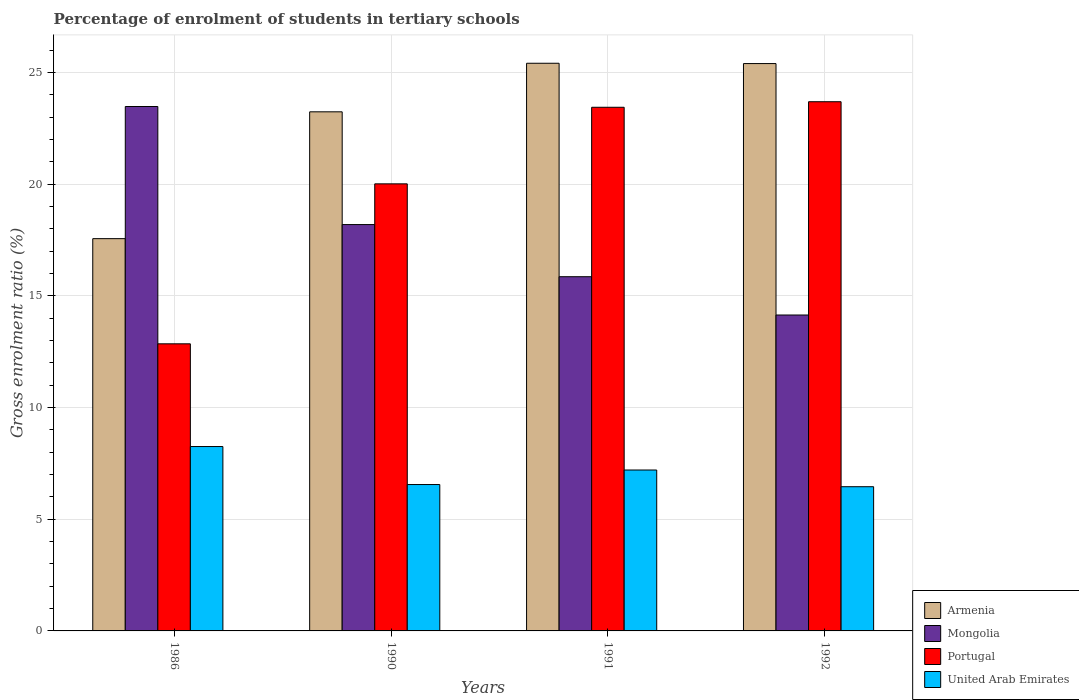How many different coloured bars are there?
Provide a short and direct response. 4. How many groups of bars are there?
Make the answer very short. 4. Are the number of bars per tick equal to the number of legend labels?
Offer a very short reply. Yes. How many bars are there on the 2nd tick from the left?
Offer a terse response. 4. What is the label of the 2nd group of bars from the left?
Provide a succinct answer. 1990. In how many cases, is the number of bars for a given year not equal to the number of legend labels?
Your answer should be very brief. 0. What is the percentage of students enrolled in tertiary schools in Portugal in 1990?
Provide a succinct answer. 20.02. Across all years, what is the maximum percentage of students enrolled in tertiary schools in United Arab Emirates?
Make the answer very short. 8.26. Across all years, what is the minimum percentage of students enrolled in tertiary schools in Portugal?
Offer a terse response. 12.86. In which year was the percentage of students enrolled in tertiary schools in Armenia maximum?
Keep it short and to the point. 1991. In which year was the percentage of students enrolled in tertiary schools in Portugal minimum?
Offer a terse response. 1986. What is the total percentage of students enrolled in tertiary schools in Mongolia in the graph?
Provide a succinct answer. 71.69. What is the difference between the percentage of students enrolled in tertiary schools in Portugal in 1991 and that in 1992?
Ensure brevity in your answer.  -0.25. What is the difference between the percentage of students enrolled in tertiary schools in Mongolia in 1986 and the percentage of students enrolled in tertiary schools in Portugal in 1990?
Your response must be concise. 3.46. What is the average percentage of students enrolled in tertiary schools in Mongolia per year?
Make the answer very short. 17.92. In the year 1990, what is the difference between the percentage of students enrolled in tertiary schools in Mongolia and percentage of students enrolled in tertiary schools in Armenia?
Your answer should be very brief. -5.05. In how many years, is the percentage of students enrolled in tertiary schools in United Arab Emirates greater than 21 %?
Make the answer very short. 0. What is the ratio of the percentage of students enrolled in tertiary schools in Armenia in 1986 to that in 1991?
Keep it short and to the point. 0.69. Is the percentage of students enrolled in tertiary schools in Portugal in 1990 less than that in 1991?
Offer a terse response. Yes. Is the difference between the percentage of students enrolled in tertiary schools in Mongolia in 1991 and 1992 greater than the difference between the percentage of students enrolled in tertiary schools in Armenia in 1991 and 1992?
Your response must be concise. Yes. What is the difference between the highest and the second highest percentage of students enrolled in tertiary schools in United Arab Emirates?
Keep it short and to the point. 1.05. What is the difference between the highest and the lowest percentage of students enrolled in tertiary schools in United Arab Emirates?
Your answer should be compact. 1.8. Is the sum of the percentage of students enrolled in tertiary schools in Portugal in 1990 and 1992 greater than the maximum percentage of students enrolled in tertiary schools in United Arab Emirates across all years?
Ensure brevity in your answer.  Yes. What does the 1st bar from the left in 1990 represents?
Offer a terse response. Armenia. What does the 3rd bar from the right in 1990 represents?
Give a very brief answer. Mongolia. How many years are there in the graph?
Your response must be concise. 4. What is the difference between two consecutive major ticks on the Y-axis?
Give a very brief answer. 5. Does the graph contain grids?
Give a very brief answer. Yes. Where does the legend appear in the graph?
Your response must be concise. Bottom right. How are the legend labels stacked?
Offer a terse response. Vertical. What is the title of the graph?
Keep it short and to the point. Percentage of enrolment of students in tertiary schools. Does "Malta" appear as one of the legend labels in the graph?
Make the answer very short. No. What is the label or title of the Y-axis?
Your answer should be very brief. Gross enrolment ratio (%). What is the Gross enrolment ratio (%) of Armenia in 1986?
Offer a terse response. 17.57. What is the Gross enrolment ratio (%) in Mongolia in 1986?
Offer a very short reply. 23.48. What is the Gross enrolment ratio (%) in Portugal in 1986?
Keep it short and to the point. 12.86. What is the Gross enrolment ratio (%) in United Arab Emirates in 1986?
Provide a succinct answer. 8.26. What is the Gross enrolment ratio (%) of Armenia in 1990?
Your answer should be very brief. 23.25. What is the Gross enrolment ratio (%) in Mongolia in 1990?
Your answer should be compact. 18.2. What is the Gross enrolment ratio (%) of Portugal in 1990?
Offer a terse response. 20.02. What is the Gross enrolment ratio (%) in United Arab Emirates in 1990?
Keep it short and to the point. 6.56. What is the Gross enrolment ratio (%) in Armenia in 1991?
Give a very brief answer. 25.42. What is the Gross enrolment ratio (%) of Mongolia in 1991?
Offer a very short reply. 15.86. What is the Gross enrolment ratio (%) in Portugal in 1991?
Provide a short and direct response. 23.45. What is the Gross enrolment ratio (%) of United Arab Emirates in 1991?
Make the answer very short. 7.21. What is the Gross enrolment ratio (%) in Armenia in 1992?
Ensure brevity in your answer.  25.41. What is the Gross enrolment ratio (%) in Mongolia in 1992?
Your response must be concise. 14.15. What is the Gross enrolment ratio (%) of Portugal in 1992?
Your answer should be very brief. 23.7. What is the Gross enrolment ratio (%) in United Arab Emirates in 1992?
Provide a short and direct response. 6.46. Across all years, what is the maximum Gross enrolment ratio (%) in Armenia?
Your response must be concise. 25.42. Across all years, what is the maximum Gross enrolment ratio (%) in Mongolia?
Offer a very short reply. 23.48. Across all years, what is the maximum Gross enrolment ratio (%) of Portugal?
Ensure brevity in your answer.  23.7. Across all years, what is the maximum Gross enrolment ratio (%) of United Arab Emirates?
Keep it short and to the point. 8.26. Across all years, what is the minimum Gross enrolment ratio (%) of Armenia?
Ensure brevity in your answer.  17.57. Across all years, what is the minimum Gross enrolment ratio (%) of Mongolia?
Your answer should be compact. 14.15. Across all years, what is the minimum Gross enrolment ratio (%) of Portugal?
Offer a terse response. 12.86. Across all years, what is the minimum Gross enrolment ratio (%) of United Arab Emirates?
Make the answer very short. 6.46. What is the total Gross enrolment ratio (%) in Armenia in the graph?
Provide a short and direct response. 91.64. What is the total Gross enrolment ratio (%) in Mongolia in the graph?
Your response must be concise. 71.69. What is the total Gross enrolment ratio (%) in Portugal in the graph?
Your answer should be compact. 80.03. What is the total Gross enrolment ratio (%) of United Arab Emirates in the graph?
Provide a short and direct response. 28.48. What is the difference between the Gross enrolment ratio (%) of Armenia in 1986 and that in 1990?
Ensure brevity in your answer.  -5.68. What is the difference between the Gross enrolment ratio (%) in Mongolia in 1986 and that in 1990?
Give a very brief answer. 5.29. What is the difference between the Gross enrolment ratio (%) of Portugal in 1986 and that in 1990?
Offer a terse response. -7.16. What is the difference between the Gross enrolment ratio (%) of United Arab Emirates in 1986 and that in 1990?
Provide a short and direct response. 1.7. What is the difference between the Gross enrolment ratio (%) in Armenia in 1986 and that in 1991?
Give a very brief answer. -7.85. What is the difference between the Gross enrolment ratio (%) of Mongolia in 1986 and that in 1991?
Offer a terse response. 7.62. What is the difference between the Gross enrolment ratio (%) of Portugal in 1986 and that in 1991?
Offer a terse response. -10.59. What is the difference between the Gross enrolment ratio (%) in United Arab Emirates in 1986 and that in 1991?
Give a very brief answer. 1.05. What is the difference between the Gross enrolment ratio (%) in Armenia in 1986 and that in 1992?
Ensure brevity in your answer.  -7.84. What is the difference between the Gross enrolment ratio (%) of Mongolia in 1986 and that in 1992?
Provide a succinct answer. 9.34. What is the difference between the Gross enrolment ratio (%) of Portugal in 1986 and that in 1992?
Your answer should be very brief. -10.84. What is the difference between the Gross enrolment ratio (%) of United Arab Emirates in 1986 and that in 1992?
Ensure brevity in your answer.  1.8. What is the difference between the Gross enrolment ratio (%) in Armenia in 1990 and that in 1991?
Provide a succinct answer. -2.17. What is the difference between the Gross enrolment ratio (%) of Mongolia in 1990 and that in 1991?
Provide a succinct answer. 2.33. What is the difference between the Gross enrolment ratio (%) in Portugal in 1990 and that in 1991?
Offer a terse response. -3.43. What is the difference between the Gross enrolment ratio (%) of United Arab Emirates in 1990 and that in 1991?
Provide a succinct answer. -0.65. What is the difference between the Gross enrolment ratio (%) in Armenia in 1990 and that in 1992?
Your answer should be very brief. -2.16. What is the difference between the Gross enrolment ratio (%) in Mongolia in 1990 and that in 1992?
Provide a short and direct response. 4.05. What is the difference between the Gross enrolment ratio (%) of Portugal in 1990 and that in 1992?
Ensure brevity in your answer.  -3.68. What is the difference between the Gross enrolment ratio (%) in United Arab Emirates in 1990 and that in 1992?
Offer a very short reply. 0.1. What is the difference between the Gross enrolment ratio (%) of Armenia in 1991 and that in 1992?
Keep it short and to the point. 0.01. What is the difference between the Gross enrolment ratio (%) in Mongolia in 1991 and that in 1992?
Provide a succinct answer. 1.72. What is the difference between the Gross enrolment ratio (%) in Portugal in 1991 and that in 1992?
Provide a succinct answer. -0.25. What is the difference between the Gross enrolment ratio (%) in United Arab Emirates in 1991 and that in 1992?
Your answer should be compact. 0.75. What is the difference between the Gross enrolment ratio (%) in Armenia in 1986 and the Gross enrolment ratio (%) in Mongolia in 1990?
Keep it short and to the point. -0.63. What is the difference between the Gross enrolment ratio (%) in Armenia in 1986 and the Gross enrolment ratio (%) in Portugal in 1990?
Ensure brevity in your answer.  -2.45. What is the difference between the Gross enrolment ratio (%) of Armenia in 1986 and the Gross enrolment ratio (%) of United Arab Emirates in 1990?
Ensure brevity in your answer.  11.01. What is the difference between the Gross enrolment ratio (%) of Mongolia in 1986 and the Gross enrolment ratio (%) of Portugal in 1990?
Provide a succinct answer. 3.46. What is the difference between the Gross enrolment ratio (%) of Mongolia in 1986 and the Gross enrolment ratio (%) of United Arab Emirates in 1990?
Provide a short and direct response. 16.93. What is the difference between the Gross enrolment ratio (%) in Portugal in 1986 and the Gross enrolment ratio (%) in United Arab Emirates in 1990?
Offer a very short reply. 6.3. What is the difference between the Gross enrolment ratio (%) of Armenia in 1986 and the Gross enrolment ratio (%) of Mongolia in 1991?
Offer a terse response. 1.7. What is the difference between the Gross enrolment ratio (%) in Armenia in 1986 and the Gross enrolment ratio (%) in Portugal in 1991?
Provide a short and direct response. -5.88. What is the difference between the Gross enrolment ratio (%) in Armenia in 1986 and the Gross enrolment ratio (%) in United Arab Emirates in 1991?
Keep it short and to the point. 10.36. What is the difference between the Gross enrolment ratio (%) of Mongolia in 1986 and the Gross enrolment ratio (%) of Portugal in 1991?
Keep it short and to the point. 0.03. What is the difference between the Gross enrolment ratio (%) of Mongolia in 1986 and the Gross enrolment ratio (%) of United Arab Emirates in 1991?
Make the answer very short. 16.28. What is the difference between the Gross enrolment ratio (%) in Portugal in 1986 and the Gross enrolment ratio (%) in United Arab Emirates in 1991?
Make the answer very short. 5.65. What is the difference between the Gross enrolment ratio (%) of Armenia in 1986 and the Gross enrolment ratio (%) of Mongolia in 1992?
Keep it short and to the point. 3.42. What is the difference between the Gross enrolment ratio (%) in Armenia in 1986 and the Gross enrolment ratio (%) in Portugal in 1992?
Keep it short and to the point. -6.13. What is the difference between the Gross enrolment ratio (%) in Armenia in 1986 and the Gross enrolment ratio (%) in United Arab Emirates in 1992?
Your answer should be very brief. 11.11. What is the difference between the Gross enrolment ratio (%) of Mongolia in 1986 and the Gross enrolment ratio (%) of Portugal in 1992?
Ensure brevity in your answer.  -0.21. What is the difference between the Gross enrolment ratio (%) in Mongolia in 1986 and the Gross enrolment ratio (%) in United Arab Emirates in 1992?
Make the answer very short. 17.03. What is the difference between the Gross enrolment ratio (%) in Portugal in 1986 and the Gross enrolment ratio (%) in United Arab Emirates in 1992?
Make the answer very short. 6.4. What is the difference between the Gross enrolment ratio (%) in Armenia in 1990 and the Gross enrolment ratio (%) in Mongolia in 1991?
Provide a short and direct response. 7.38. What is the difference between the Gross enrolment ratio (%) of Armenia in 1990 and the Gross enrolment ratio (%) of Portugal in 1991?
Offer a terse response. -0.2. What is the difference between the Gross enrolment ratio (%) of Armenia in 1990 and the Gross enrolment ratio (%) of United Arab Emirates in 1991?
Offer a very short reply. 16.04. What is the difference between the Gross enrolment ratio (%) of Mongolia in 1990 and the Gross enrolment ratio (%) of Portugal in 1991?
Your answer should be very brief. -5.25. What is the difference between the Gross enrolment ratio (%) of Mongolia in 1990 and the Gross enrolment ratio (%) of United Arab Emirates in 1991?
Give a very brief answer. 10.99. What is the difference between the Gross enrolment ratio (%) of Portugal in 1990 and the Gross enrolment ratio (%) of United Arab Emirates in 1991?
Your answer should be compact. 12.81. What is the difference between the Gross enrolment ratio (%) in Armenia in 1990 and the Gross enrolment ratio (%) in Mongolia in 1992?
Offer a very short reply. 9.1. What is the difference between the Gross enrolment ratio (%) in Armenia in 1990 and the Gross enrolment ratio (%) in Portugal in 1992?
Ensure brevity in your answer.  -0.45. What is the difference between the Gross enrolment ratio (%) in Armenia in 1990 and the Gross enrolment ratio (%) in United Arab Emirates in 1992?
Offer a terse response. 16.79. What is the difference between the Gross enrolment ratio (%) of Mongolia in 1990 and the Gross enrolment ratio (%) of Portugal in 1992?
Provide a succinct answer. -5.5. What is the difference between the Gross enrolment ratio (%) in Mongolia in 1990 and the Gross enrolment ratio (%) in United Arab Emirates in 1992?
Give a very brief answer. 11.74. What is the difference between the Gross enrolment ratio (%) in Portugal in 1990 and the Gross enrolment ratio (%) in United Arab Emirates in 1992?
Your response must be concise. 13.56. What is the difference between the Gross enrolment ratio (%) of Armenia in 1991 and the Gross enrolment ratio (%) of Mongolia in 1992?
Provide a short and direct response. 11.27. What is the difference between the Gross enrolment ratio (%) of Armenia in 1991 and the Gross enrolment ratio (%) of Portugal in 1992?
Ensure brevity in your answer.  1.72. What is the difference between the Gross enrolment ratio (%) in Armenia in 1991 and the Gross enrolment ratio (%) in United Arab Emirates in 1992?
Keep it short and to the point. 18.96. What is the difference between the Gross enrolment ratio (%) of Mongolia in 1991 and the Gross enrolment ratio (%) of Portugal in 1992?
Offer a very short reply. -7.84. What is the difference between the Gross enrolment ratio (%) in Mongolia in 1991 and the Gross enrolment ratio (%) in United Arab Emirates in 1992?
Ensure brevity in your answer.  9.4. What is the difference between the Gross enrolment ratio (%) in Portugal in 1991 and the Gross enrolment ratio (%) in United Arab Emirates in 1992?
Give a very brief answer. 16.99. What is the average Gross enrolment ratio (%) in Armenia per year?
Offer a terse response. 22.91. What is the average Gross enrolment ratio (%) in Mongolia per year?
Give a very brief answer. 17.92. What is the average Gross enrolment ratio (%) of Portugal per year?
Keep it short and to the point. 20.01. What is the average Gross enrolment ratio (%) of United Arab Emirates per year?
Offer a terse response. 7.12. In the year 1986, what is the difference between the Gross enrolment ratio (%) in Armenia and Gross enrolment ratio (%) in Mongolia?
Provide a succinct answer. -5.92. In the year 1986, what is the difference between the Gross enrolment ratio (%) in Armenia and Gross enrolment ratio (%) in Portugal?
Offer a very short reply. 4.71. In the year 1986, what is the difference between the Gross enrolment ratio (%) in Armenia and Gross enrolment ratio (%) in United Arab Emirates?
Your answer should be very brief. 9.31. In the year 1986, what is the difference between the Gross enrolment ratio (%) of Mongolia and Gross enrolment ratio (%) of Portugal?
Provide a short and direct response. 10.63. In the year 1986, what is the difference between the Gross enrolment ratio (%) of Mongolia and Gross enrolment ratio (%) of United Arab Emirates?
Keep it short and to the point. 15.23. In the year 1986, what is the difference between the Gross enrolment ratio (%) of Portugal and Gross enrolment ratio (%) of United Arab Emirates?
Your response must be concise. 4.6. In the year 1990, what is the difference between the Gross enrolment ratio (%) in Armenia and Gross enrolment ratio (%) in Mongolia?
Provide a short and direct response. 5.05. In the year 1990, what is the difference between the Gross enrolment ratio (%) of Armenia and Gross enrolment ratio (%) of Portugal?
Your answer should be very brief. 3.23. In the year 1990, what is the difference between the Gross enrolment ratio (%) in Armenia and Gross enrolment ratio (%) in United Arab Emirates?
Your answer should be very brief. 16.69. In the year 1990, what is the difference between the Gross enrolment ratio (%) of Mongolia and Gross enrolment ratio (%) of Portugal?
Give a very brief answer. -1.82. In the year 1990, what is the difference between the Gross enrolment ratio (%) in Mongolia and Gross enrolment ratio (%) in United Arab Emirates?
Your answer should be compact. 11.64. In the year 1990, what is the difference between the Gross enrolment ratio (%) in Portugal and Gross enrolment ratio (%) in United Arab Emirates?
Offer a very short reply. 13.47. In the year 1991, what is the difference between the Gross enrolment ratio (%) of Armenia and Gross enrolment ratio (%) of Mongolia?
Offer a very short reply. 9.56. In the year 1991, what is the difference between the Gross enrolment ratio (%) of Armenia and Gross enrolment ratio (%) of Portugal?
Your response must be concise. 1.97. In the year 1991, what is the difference between the Gross enrolment ratio (%) of Armenia and Gross enrolment ratio (%) of United Arab Emirates?
Offer a very short reply. 18.21. In the year 1991, what is the difference between the Gross enrolment ratio (%) in Mongolia and Gross enrolment ratio (%) in Portugal?
Your response must be concise. -7.59. In the year 1991, what is the difference between the Gross enrolment ratio (%) in Mongolia and Gross enrolment ratio (%) in United Arab Emirates?
Your response must be concise. 8.66. In the year 1991, what is the difference between the Gross enrolment ratio (%) in Portugal and Gross enrolment ratio (%) in United Arab Emirates?
Your response must be concise. 16.24. In the year 1992, what is the difference between the Gross enrolment ratio (%) in Armenia and Gross enrolment ratio (%) in Mongolia?
Offer a terse response. 11.26. In the year 1992, what is the difference between the Gross enrolment ratio (%) in Armenia and Gross enrolment ratio (%) in Portugal?
Provide a short and direct response. 1.71. In the year 1992, what is the difference between the Gross enrolment ratio (%) in Armenia and Gross enrolment ratio (%) in United Arab Emirates?
Your answer should be compact. 18.95. In the year 1992, what is the difference between the Gross enrolment ratio (%) of Mongolia and Gross enrolment ratio (%) of Portugal?
Make the answer very short. -9.55. In the year 1992, what is the difference between the Gross enrolment ratio (%) in Mongolia and Gross enrolment ratio (%) in United Arab Emirates?
Provide a succinct answer. 7.69. In the year 1992, what is the difference between the Gross enrolment ratio (%) in Portugal and Gross enrolment ratio (%) in United Arab Emirates?
Make the answer very short. 17.24. What is the ratio of the Gross enrolment ratio (%) in Armenia in 1986 to that in 1990?
Ensure brevity in your answer.  0.76. What is the ratio of the Gross enrolment ratio (%) in Mongolia in 1986 to that in 1990?
Offer a terse response. 1.29. What is the ratio of the Gross enrolment ratio (%) of Portugal in 1986 to that in 1990?
Offer a very short reply. 0.64. What is the ratio of the Gross enrolment ratio (%) in United Arab Emirates in 1986 to that in 1990?
Provide a short and direct response. 1.26. What is the ratio of the Gross enrolment ratio (%) of Armenia in 1986 to that in 1991?
Make the answer very short. 0.69. What is the ratio of the Gross enrolment ratio (%) of Mongolia in 1986 to that in 1991?
Keep it short and to the point. 1.48. What is the ratio of the Gross enrolment ratio (%) of Portugal in 1986 to that in 1991?
Ensure brevity in your answer.  0.55. What is the ratio of the Gross enrolment ratio (%) in United Arab Emirates in 1986 to that in 1991?
Give a very brief answer. 1.15. What is the ratio of the Gross enrolment ratio (%) in Armenia in 1986 to that in 1992?
Your response must be concise. 0.69. What is the ratio of the Gross enrolment ratio (%) in Mongolia in 1986 to that in 1992?
Provide a short and direct response. 1.66. What is the ratio of the Gross enrolment ratio (%) in Portugal in 1986 to that in 1992?
Offer a very short reply. 0.54. What is the ratio of the Gross enrolment ratio (%) in United Arab Emirates in 1986 to that in 1992?
Your answer should be compact. 1.28. What is the ratio of the Gross enrolment ratio (%) of Armenia in 1990 to that in 1991?
Give a very brief answer. 0.91. What is the ratio of the Gross enrolment ratio (%) of Mongolia in 1990 to that in 1991?
Make the answer very short. 1.15. What is the ratio of the Gross enrolment ratio (%) in Portugal in 1990 to that in 1991?
Make the answer very short. 0.85. What is the ratio of the Gross enrolment ratio (%) in United Arab Emirates in 1990 to that in 1991?
Give a very brief answer. 0.91. What is the ratio of the Gross enrolment ratio (%) in Armenia in 1990 to that in 1992?
Give a very brief answer. 0.92. What is the ratio of the Gross enrolment ratio (%) in Mongolia in 1990 to that in 1992?
Keep it short and to the point. 1.29. What is the ratio of the Gross enrolment ratio (%) of Portugal in 1990 to that in 1992?
Provide a short and direct response. 0.84. What is the ratio of the Gross enrolment ratio (%) of United Arab Emirates in 1990 to that in 1992?
Your response must be concise. 1.02. What is the ratio of the Gross enrolment ratio (%) in Armenia in 1991 to that in 1992?
Your response must be concise. 1. What is the ratio of the Gross enrolment ratio (%) of Mongolia in 1991 to that in 1992?
Your answer should be very brief. 1.12. What is the ratio of the Gross enrolment ratio (%) of Portugal in 1991 to that in 1992?
Ensure brevity in your answer.  0.99. What is the ratio of the Gross enrolment ratio (%) in United Arab Emirates in 1991 to that in 1992?
Provide a succinct answer. 1.12. What is the difference between the highest and the second highest Gross enrolment ratio (%) in Armenia?
Provide a succinct answer. 0.01. What is the difference between the highest and the second highest Gross enrolment ratio (%) in Mongolia?
Offer a very short reply. 5.29. What is the difference between the highest and the second highest Gross enrolment ratio (%) of Portugal?
Your answer should be compact. 0.25. What is the difference between the highest and the second highest Gross enrolment ratio (%) of United Arab Emirates?
Provide a succinct answer. 1.05. What is the difference between the highest and the lowest Gross enrolment ratio (%) of Armenia?
Your response must be concise. 7.85. What is the difference between the highest and the lowest Gross enrolment ratio (%) of Mongolia?
Keep it short and to the point. 9.34. What is the difference between the highest and the lowest Gross enrolment ratio (%) in Portugal?
Keep it short and to the point. 10.84. What is the difference between the highest and the lowest Gross enrolment ratio (%) in United Arab Emirates?
Keep it short and to the point. 1.8. 